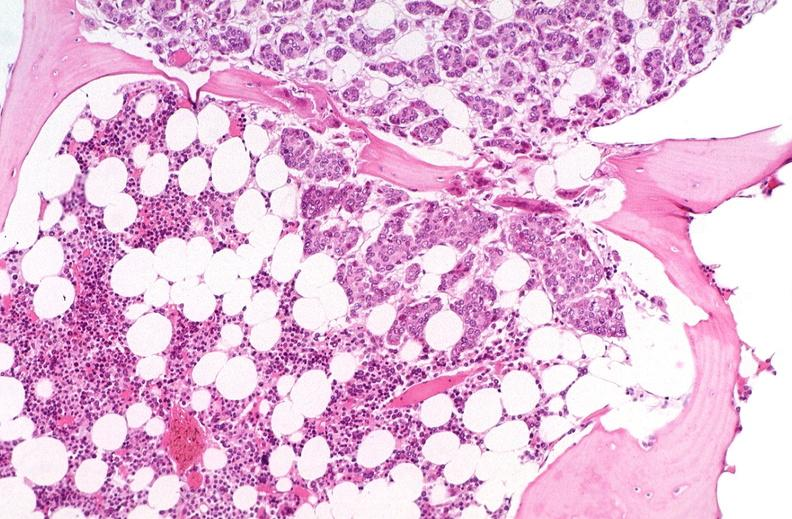what does this image show?
Answer the question using a single word or phrase. Breast cancer metastasis to bone marrow 